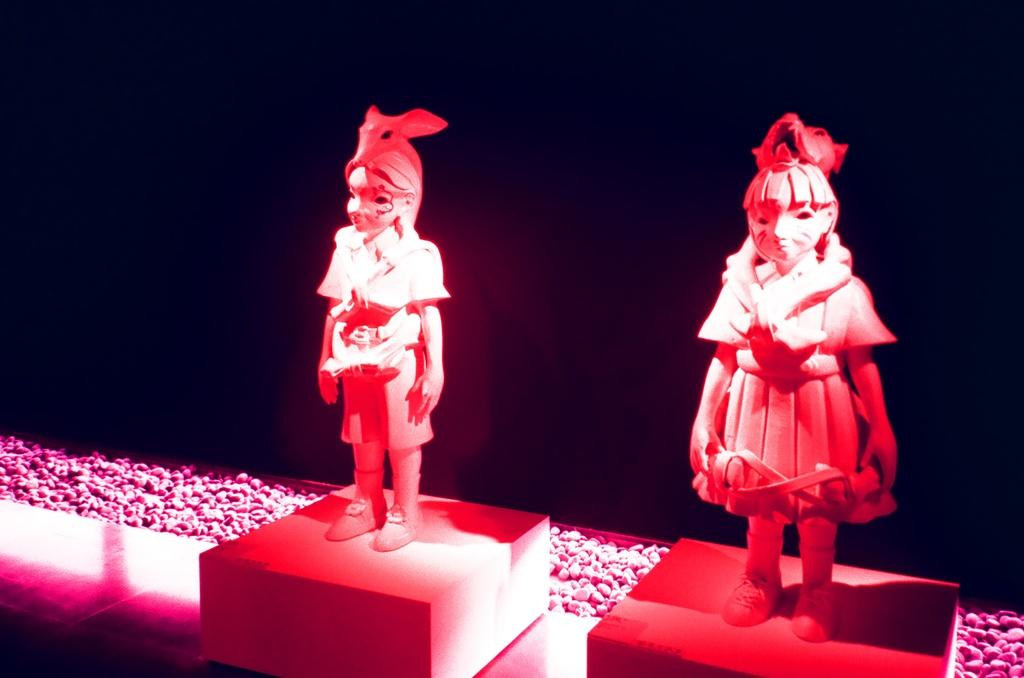What are the main subjects in the image? There are two persons depicted as statues in the image. Where are the statues located? The statues are on the floor. What can be seen in the background of the image? There are stones visible in the background of the image. What is the color scheme of the image? The image has a dark color scheme. When was the image taken? The image was taken in a hall during nighttime. What type of suit is the statue wearing in the image? There are no suits present in the image, as the subjects are statues and not dressed in clothing. 